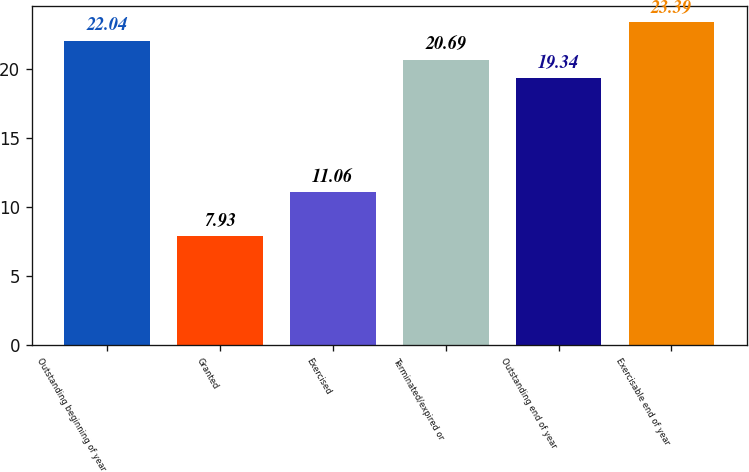Convert chart to OTSL. <chart><loc_0><loc_0><loc_500><loc_500><bar_chart><fcel>Outstanding beginning of year<fcel>Granted<fcel>Exercised<fcel>Terminated/expired or<fcel>Outstanding end of year<fcel>Exercisable end of year<nl><fcel>22.04<fcel>7.93<fcel>11.06<fcel>20.69<fcel>19.34<fcel>23.39<nl></chart> 